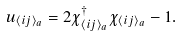Convert formula to latex. <formula><loc_0><loc_0><loc_500><loc_500>u _ { \langle i j \rangle _ { a } } = 2 \chi ^ { \dagger } _ { \langle i j \rangle _ { a } } \chi _ { \langle i j \rangle _ { a } } - 1 .</formula> 